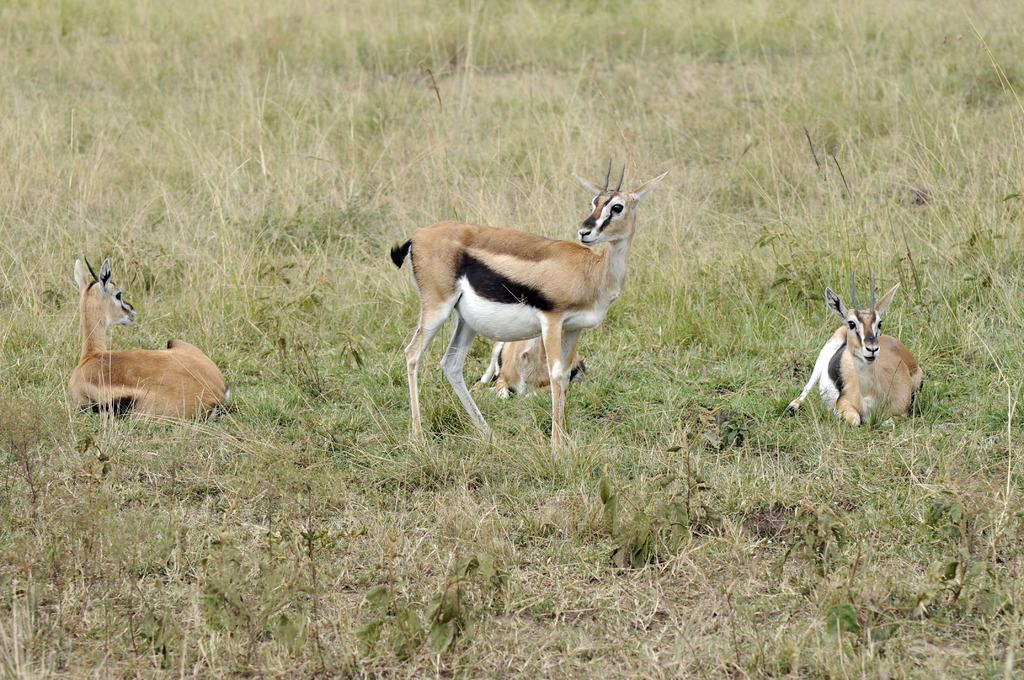What type of living organisms are present in the image? There are animals in the image. What colors can be seen on the animals? The animals have brown, white, and black colors. What type of vegetation is visible in the image? There is green grass and dry grass in the image. What type of treatment is being administered to the animals in the image? There is no indication in the image that any treatment is being administered to the animals. 